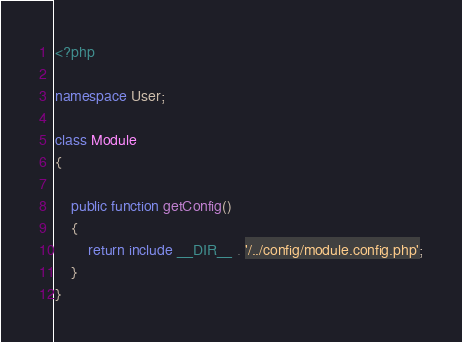<code> <loc_0><loc_0><loc_500><loc_500><_PHP_><?php

namespace User;

class Module
{

    public function getConfig()
    {
        return include __DIR__ . '/../config/module.config.php';
    }
}
</code> 